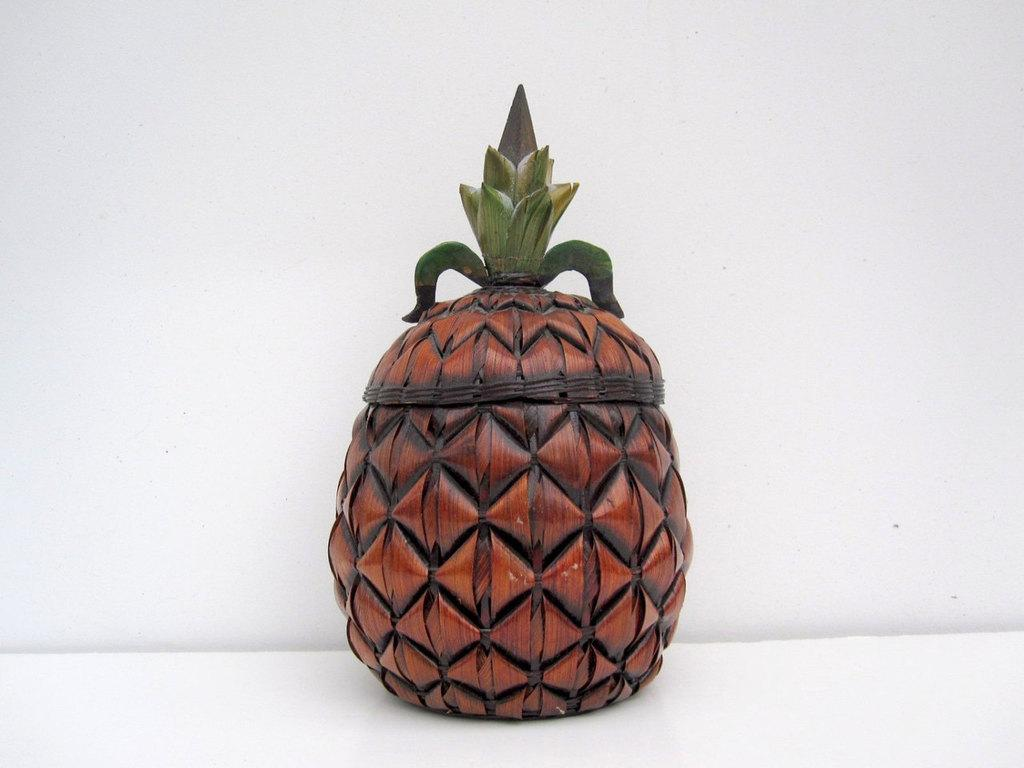What is the main object in the center of the image? There is a jar in the shape of a pineapple in the center of the image. What can be seen in the background of the image? There is a wall in the background of the image. What is located at the bottom of the image? There is a table at the bottom of the image. What type of brass instrument is being played in the image? There is no brass instrument or any indication of music being played in the image. 